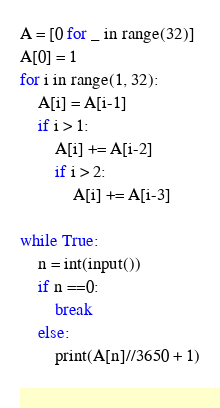Convert code to text. <code><loc_0><loc_0><loc_500><loc_500><_Python_>A = [0 for _ in range(32)]
A[0] = 1
for i in range(1, 32):
    A[i] = A[i-1]
    if i > 1:
        A[i] += A[i-2]
        if i > 2:
            A[i] += A[i-3]

while True:
    n = int(input())
    if n ==0:
        break
    else:
        print(A[n]//3650 + 1)
    



</code> 